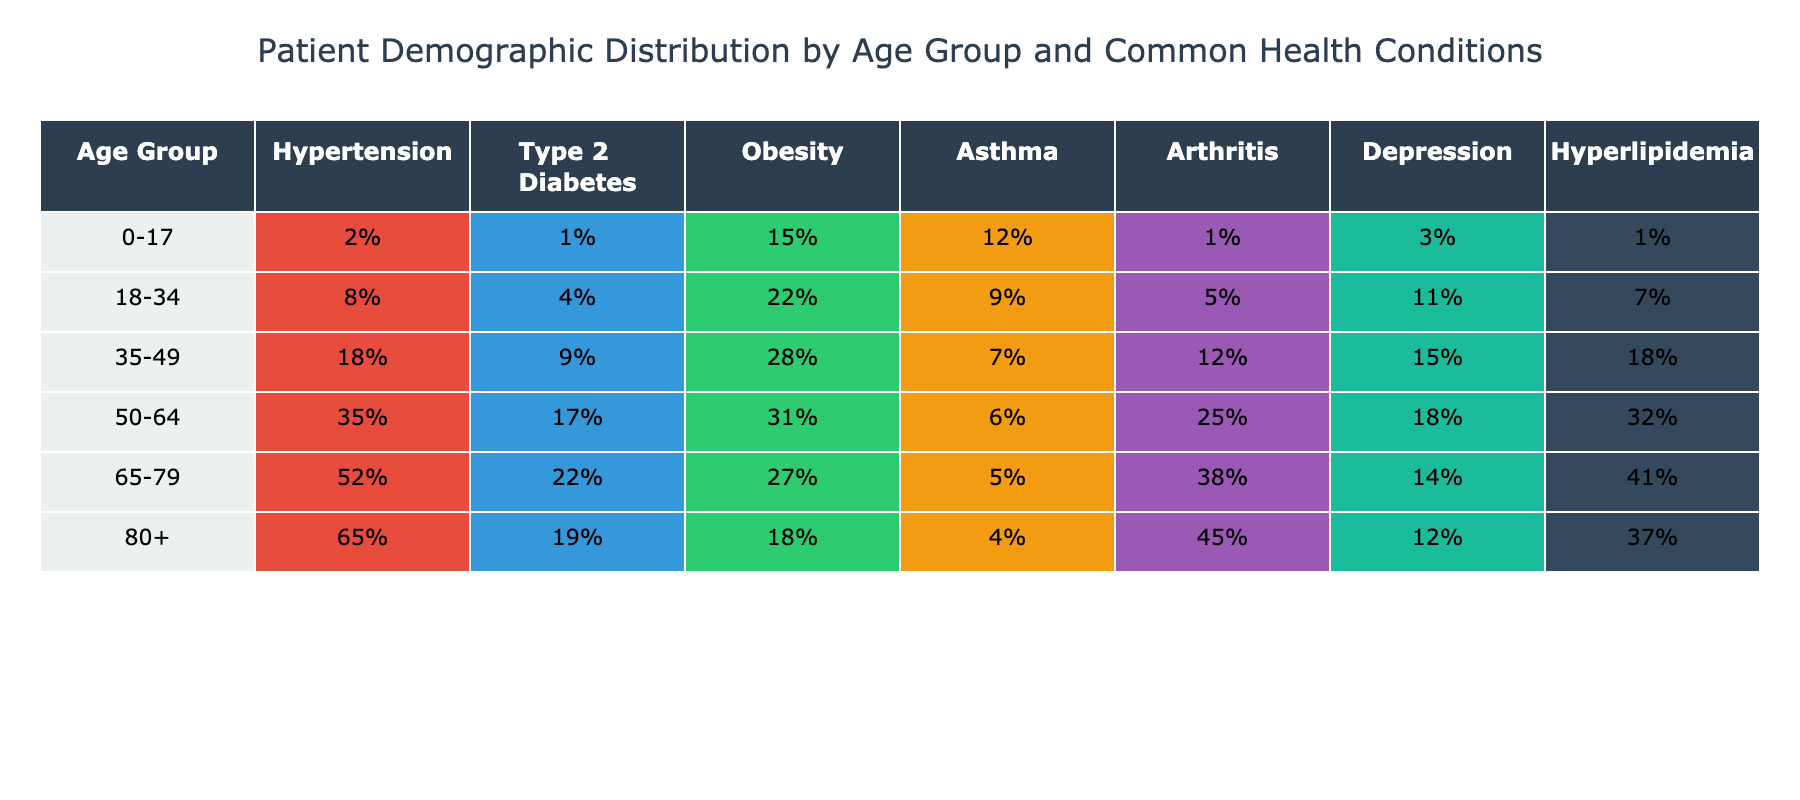What percentage of patients aged 65-79 have hypertension? In the age group of 65-79, the table shows that 52% of patients have hypertension.
Answer: 52% Which age group has the highest percentage of obesity? The table indicates that the age group 35-49 has the highest percentage of obesity at 28%.
Answer: 28% Is there more prevalence of asthma in the 0-17 age group compared to the 50-64 age group? According to the table, 12% of patients aged 0-17 have asthma while 6% of those aged 50-64 do. Therefore, asthma is more prevalent in the 0-17 age group.
Answer: Yes What is the difference in the percentage of depression between the 18-34 and 50-64 age groups? The percentage of depression in the 18-34 age group is 11%, and in the 50-64 age group it is 18%. The difference is 18% - 11% = 7%.
Answer: 7% What is the average percentage of hyperlipidemia across all age groups? Adding the hyperlipidemia percentages gives 1% + 7% + 18% + 32% + 41% + 37% = 136%. Dividing by the 6 age groups gives 136% / 6 = 22.67%.
Answer: 22.67% Does the prevalence of type 2 diabetes increase with age? Observing the table, 1% in 0-17, 4% in 18-34, 9% in 35-49, 17% in 50-64, 22% in 65-79, and 19% in 80+. The trend shows a general increase until the 65-79 age group, after which it slightly decreases. Therefore, it does not continuously increase with age.
Answer: No Which age group has the lowest percentage of arthritis? According to the table, the 0-17 age group has the lowest percentage of arthritis at 1%.
Answer: 1% What is the total percentage of patients with hypertension and type 2 diabetes in the 35-49 age group? From the table, in the 35-49 age group, hypertension is at 18% and type 2 diabetes at 9%. Adding these together gives a total of 18% + 9% = 27%.
Answer: 27% What percentage of patients aged 80+ have obesity and what is it compared to the 50-64 age group? The percentage of obesity for the 80+ age group is 18% and for 50-64 it is 31%. Therefore, 18% is 31% - 18% = 13% lower than the 50-64 group.
Answer: 13% lower Which health condition shows the most significant increase in prevalence from the 18-34 age group to the 50-64 age group? Looking at the table, hypertension increases from 8% (18-34) to 35% (50-64), which is an increase of 27%. Comparing with other conditions, this is the highest increase.
Answer: Hypertension (27% increase) What percentage of patients aged 0-17 have neither hypertension nor type 2 diabetes? In the 0-17 age group, 2% have hypertension and 1% have type 2 diabetes. The total for these two conditions is 2% + 1% = 3%. Therefore, the percentage with neither is 100% - 3% = 97%.
Answer: 97% 